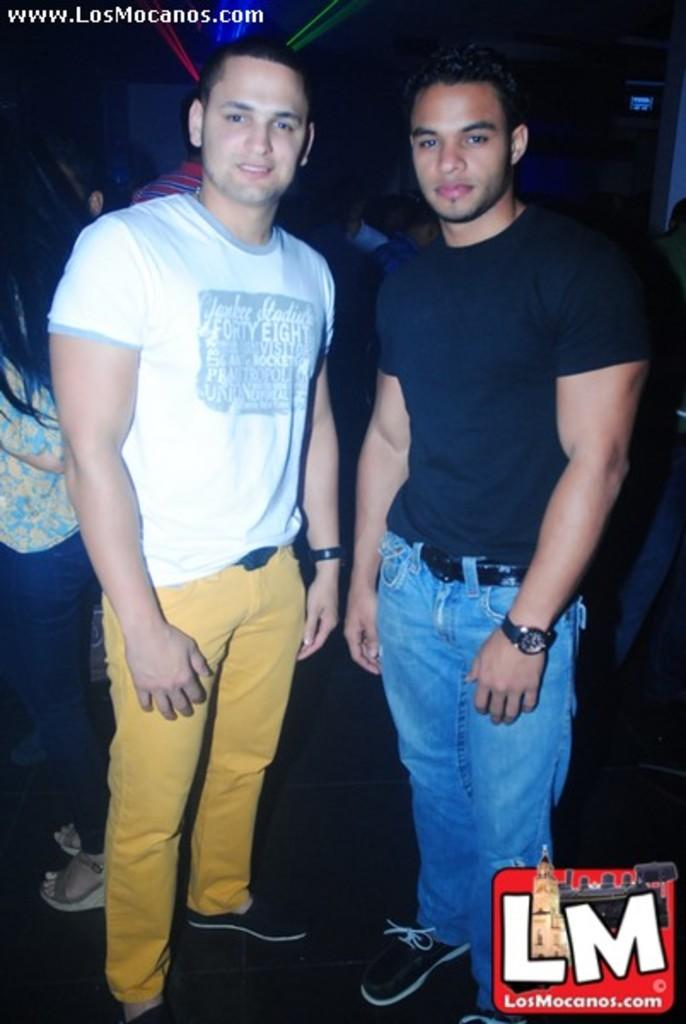What are the people in the image doing? The people in the image are standing on the floor. How would you describe the background of the image? The background of the image is dark with lights. Are there any visible watermarks in the image? Yes, there are watermarks present in the image. Can you tell me how many beetles are crawling on the floor in the image? There are no beetles present in the image; it only features people standing on the floor. What level of difficulty is the image set at? The image does not have a level of difficulty, as it is a static representation and not a game or challenge. 